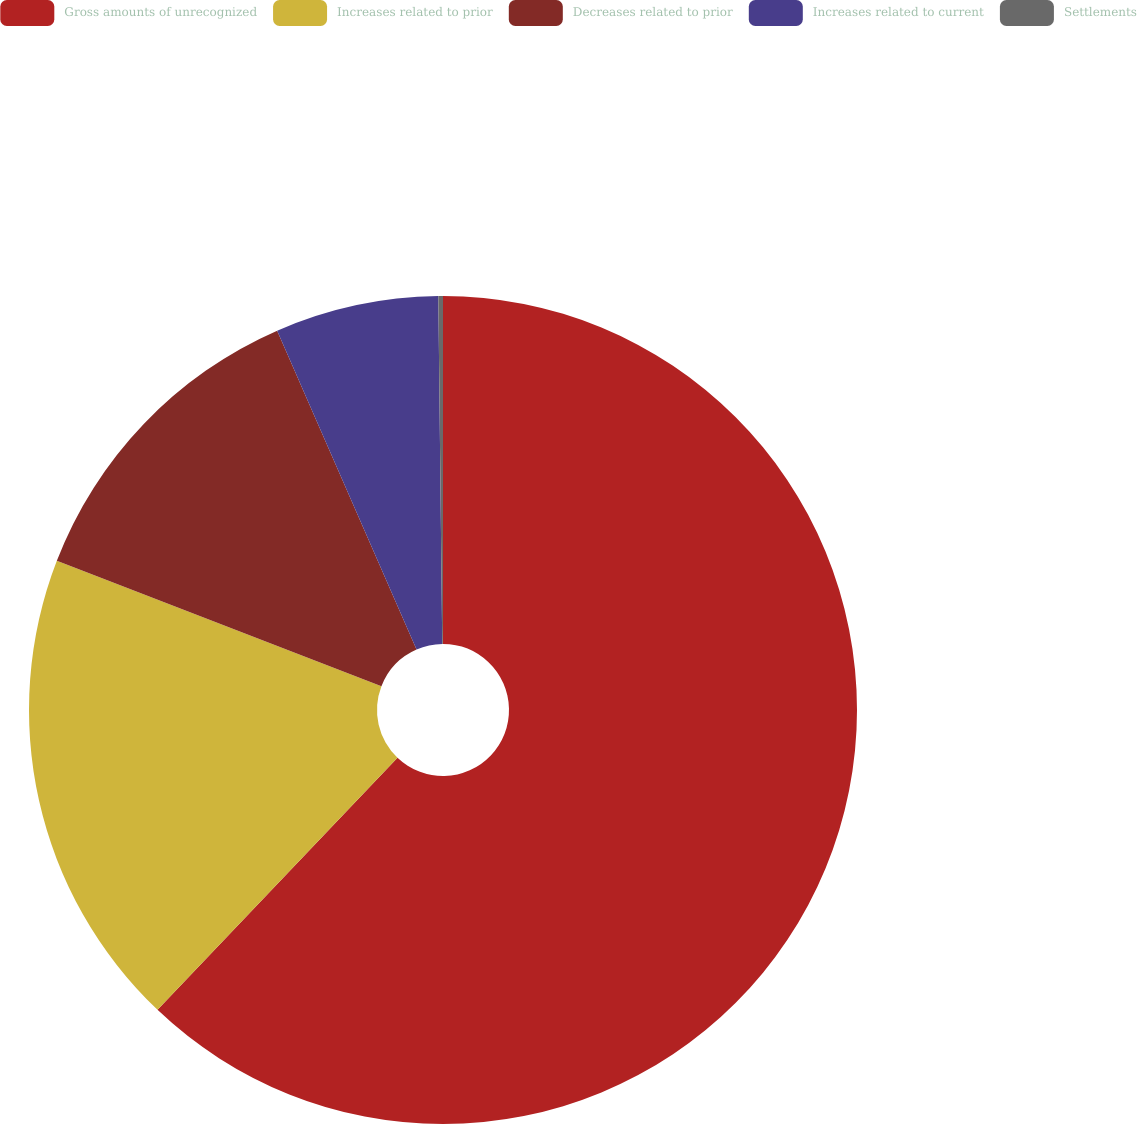<chart> <loc_0><loc_0><loc_500><loc_500><pie_chart><fcel>Gross amounts of unrecognized<fcel>Increases related to prior<fcel>Decreases related to prior<fcel>Increases related to current<fcel>Settlements<nl><fcel>62.11%<fcel>18.76%<fcel>12.57%<fcel>6.38%<fcel>0.18%<nl></chart> 